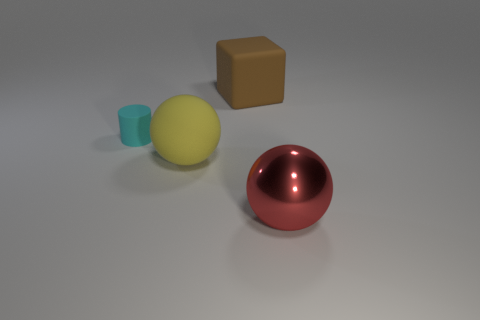Add 2 tiny green rubber cylinders. How many objects exist? 6 Subtract all cylinders. How many objects are left? 3 Add 2 small purple matte objects. How many small purple matte objects exist? 2 Subtract 0 cyan blocks. How many objects are left? 4 Subtract all cyan cylinders. Subtract all large objects. How many objects are left? 0 Add 4 small rubber cylinders. How many small rubber cylinders are left? 5 